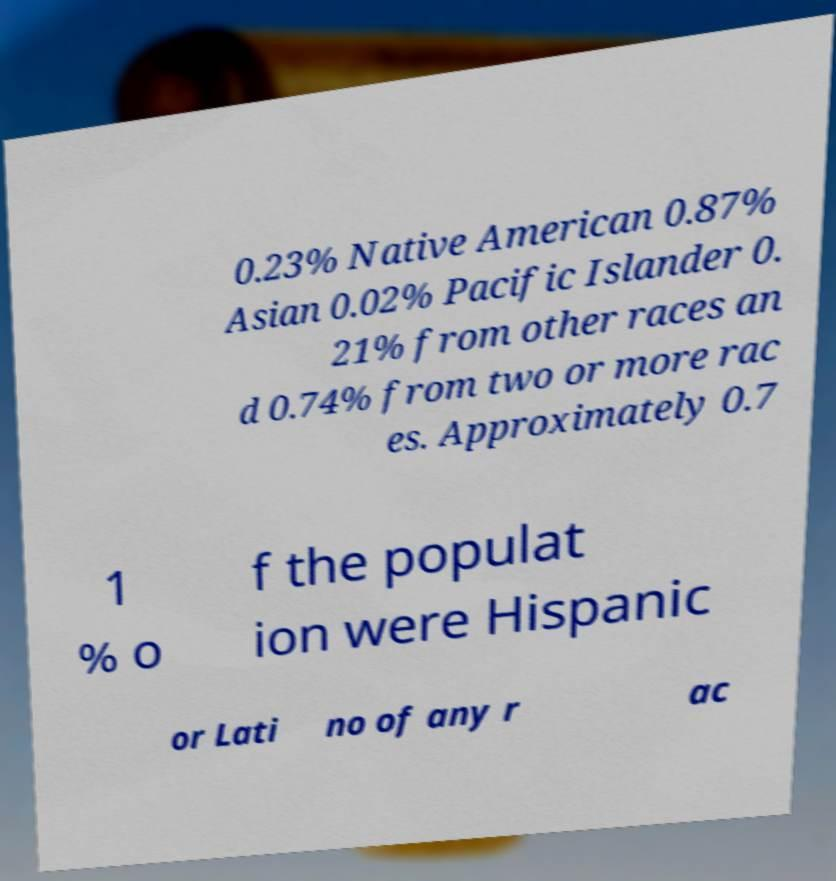What messages or text are displayed in this image? I need them in a readable, typed format. 0.23% Native American 0.87% Asian 0.02% Pacific Islander 0. 21% from other races an d 0.74% from two or more rac es. Approximately 0.7 1 % o f the populat ion were Hispanic or Lati no of any r ac 